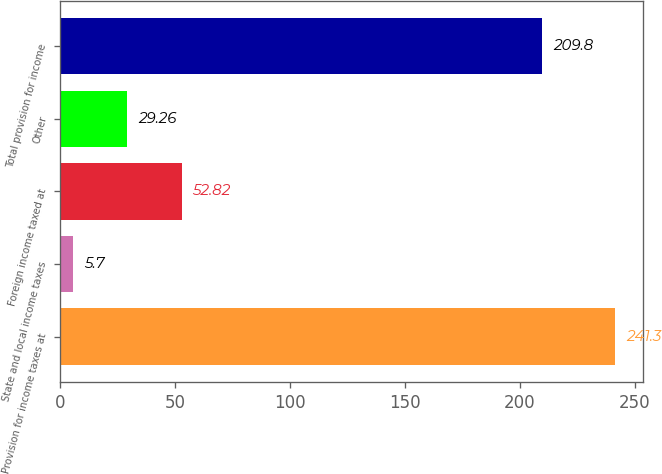Convert chart to OTSL. <chart><loc_0><loc_0><loc_500><loc_500><bar_chart><fcel>Provision for income taxes at<fcel>State and local income taxes<fcel>Foreign income taxed at<fcel>Other<fcel>Total provision for income<nl><fcel>241.3<fcel>5.7<fcel>52.82<fcel>29.26<fcel>209.8<nl></chart> 